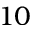<formula> <loc_0><loc_0><loc_500><loc_500>1 0</formula> 